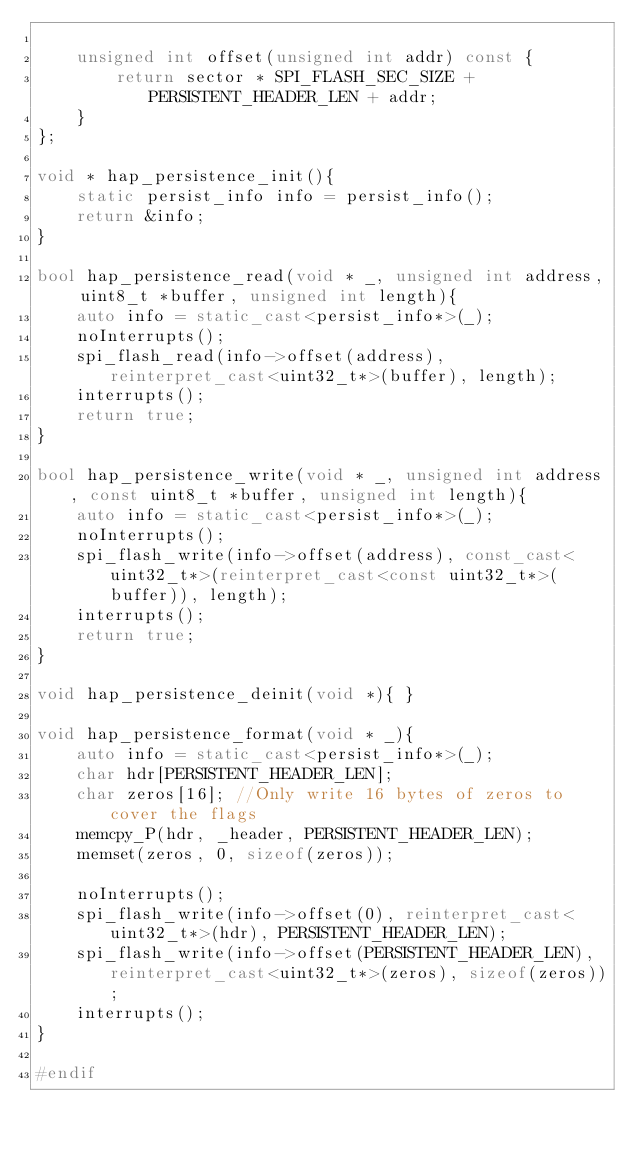<code> <loc_0><loc_0><loc_500><loc_500><_C++_>
    unsigned int offset(unsigned int addr) const {
        return sector * SPI_FLASH_SEC_SIZE + PERSISTENT_HEADER_LEN + addr;
    }
};

void * hap_persistence_init(){
    static persist_info info = persist_info();
    return &info;
}

bool hap_persistence_read(void * _, unsigned int address, uint8_t *buffer, unsigned int length){
    auto info = static_cast<persist_info*>(_);
    noInterrupts();
    spi_flash_read(info->offset(address), reinterpret_cast<uint32_t*>(buffer), length);
    interrupts();
    return true;
}

bool hap_persistence_write(void * _, unsigned int address, const uint8_t *buffer, unsigned int length){
    auto info = static_cast<persist_info*>(_);
    noInterrupts();
    spi_flash_write(info->offset(address), const_cast<uint32_t*>(reinterpret_cast<const uint32_t*>(buffer)), length);
    interrupts();
    return true;
}

void hap_persistence_deinit(void *){ }

void hap_persistence_format(void * _){
    auto info = static_cast<persist_info*>(_);
    char hdr[PERSISTENT_HEADER_LEN];
    char zeros[16]; //Only write 16 bytes of zeros to cover the flags
    memcpy_P(hdr, _header, PERSISTENT_HEADER_LEN);
    memset(zeros, 0, sizeof(zeros));

    noInterrupts();
    spi_flash_write(info->offset(0), reinterpret_cast<uint32_t*>(hdr), PERSISTENT_HEADER_LEN);
    spi_flash_write(info->offset(PERSISTENT_HEADER_LEN), reinterpret_cast<uint32_t*>(zeros), sizeof(zeros));
    interrupts();
}

#endif
</code> 